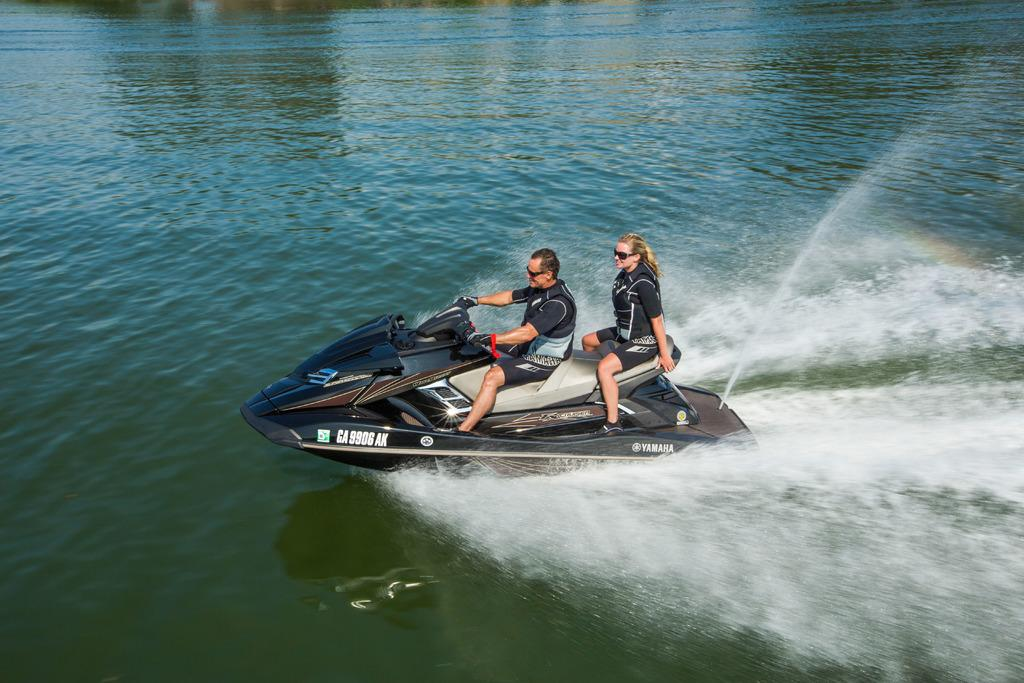What is the main subject in the image? The main subject in the image is a speed boat. What is the color of the speed boat? The speed boat is black in color. Where is the speed boat located in the image? The speed boat is on the surface of the water. How many people are on the speed boat? There are two persons sitting on the speed boat. What type of hat is the person wearing on the table in the image? There is no hat or table present in the image; it features a speed boat on the water with two people on it. 